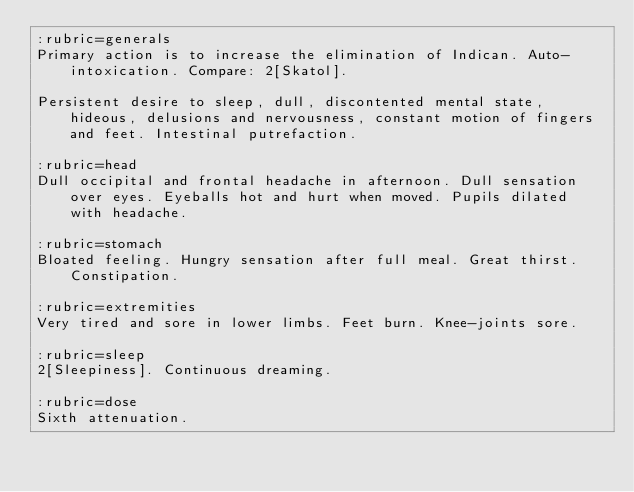Convert code to text. <code><loc_0><loc_0><loc_500><loc_500><_ObjectiveC_>:rubric=generals
Primary action is to increase the elimination of Indican. Auto-intoxication. Compare: 2[Skatol].

Persistent desire to sleep, dull, discontented mental state, hideous, delusions and nervousness, constant motion of fingers and feet. Intestinal putrefaction.

:rubric=head
Dull occipital and frontal headache in afternoon. Dull sensation over eyes. Eyeballs hot and hurt when moved. Pupils dilated with headache.

:rubric=stomach
Bloated feeling. Hungry sensation after full meal. Great thirst. Constipation.

:rubric=extremities
Very tired and sore in lower limbs. Feet burn. Knee-joints sore.

:rubric=sleep
2[Sleepiness]. Continuous dreaming.

:rubric=dose
Sixth attenuation.

</code> 